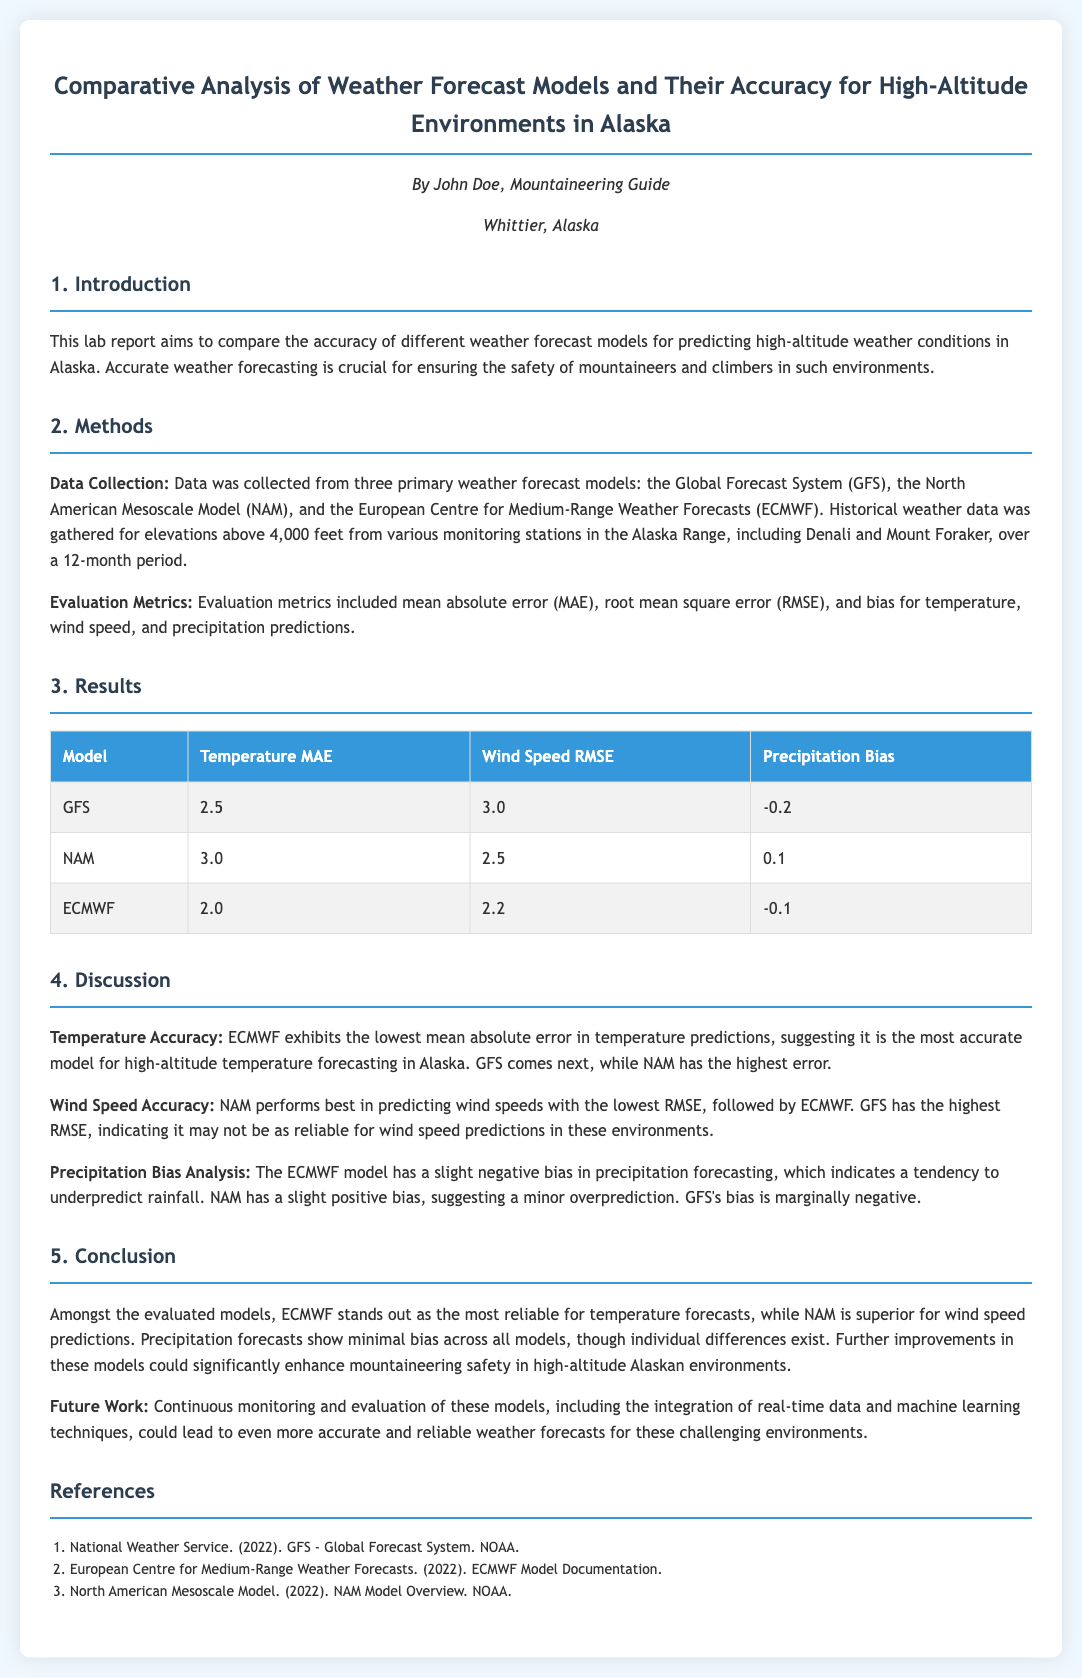What is the main focus of the lab report? The main focus of the lab report is to compare the accuracy of different weather forecast models for predicting high-altitude weather conditions in Alaska.
Answer: comparing weather forecast models Which weather forecast model has the lowest mean absolute error for temperature? The model with the lowest mean absolute error for temperature is ECMWF.
Answer: ECMWF What is the wind speed RMSE for the NAM model? The wind speed RMSE for the NAM model is 2.5.
Answer: 2.5 Which model shows a positive bias in precipitation forecasting? The model that shows a positive bias in precipitation forecasting is NAM.
Answer: NAM What type of errors were evaluated in this report? The types of errors evaluated include mean absolute error, root mean square error, and bias.
Answer: MAE, RMSE, bias Who is the author of the report? The author of the report is John Doe.
Answer: John Doe What does ECMWF stand for? ECMWF stands for the European Centre for Medium-Range Weather Forecasts.
Answer: European Centre for Medium-Range Weather Forecasts Which model is considered the most reliable for wind speed predictions? The model considered the most reliable for wind speed predictions is NAM.
Answer: NAM 